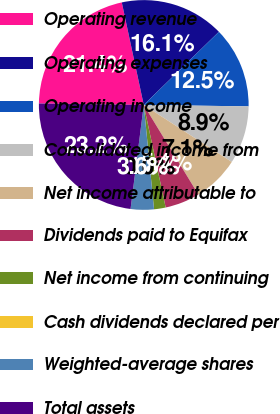Convert chart to OTSL. <chart><loc_0><loc_0><loc_500><loc_500><pie_chart><fcel>Operating revenue<fcel>Operating expenses<fcel>Operating income<fcel>Consolidated income from<fcel>Net income attributable to<fcel>Dividends paid to Equifax<fcel>Net income from continuing<fcel>Cash dividends declared per<fcel>Weighted-average shares<fcel>Total assets<nl><fcel>21.42%<fcel>16.07%<fcel>12.5%<fcel>8.93%<fcel>7.14%<fcel>5.36%<fcel>1.79%<fcel>0.0%<fcel>3.57%<fcel>23.21%<nl></chart> 